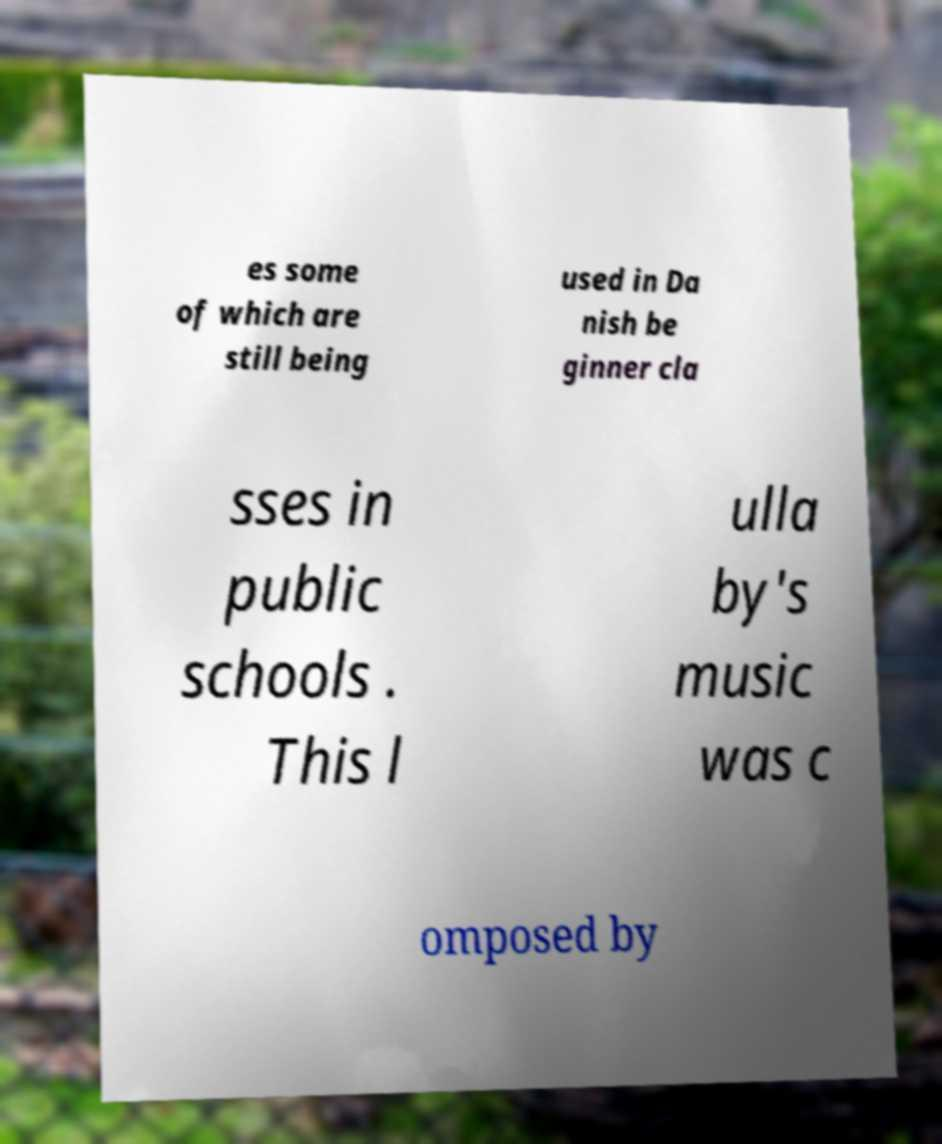Can you accurately transcribe the text from the provided image for me? es some of which are still being used in Da nish be ginner cla sses in public schools . This l ulla by's music was c omposed by 